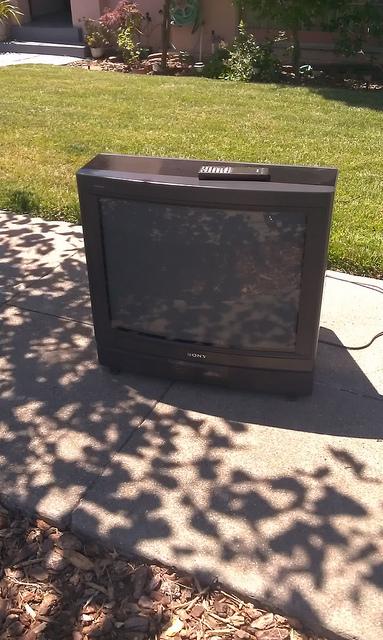What is the TV sitting on?
Give a very brief answer. Sidewalk. What is the color of the grass?
Keep it brief. Green. What appliance is this?
Be succinct. Tv. 